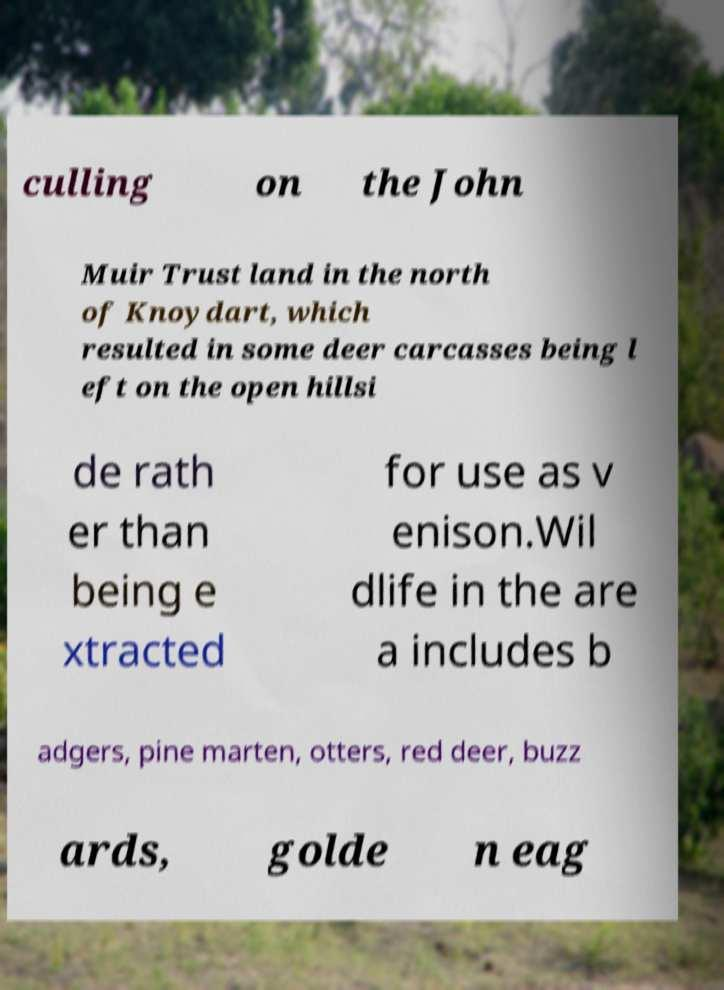I need the written content from this picture converted into text. Can you do that? culling on the John Muir Trust land in the north of Knoydart, which resulted in some deer carcasses being l eft on the open hillsi de rath er than being e xtracted for use as v enison.Wil dlife in the are a includes b adgers, pine marten, otters, red deer, buzz ards, golde n eag 